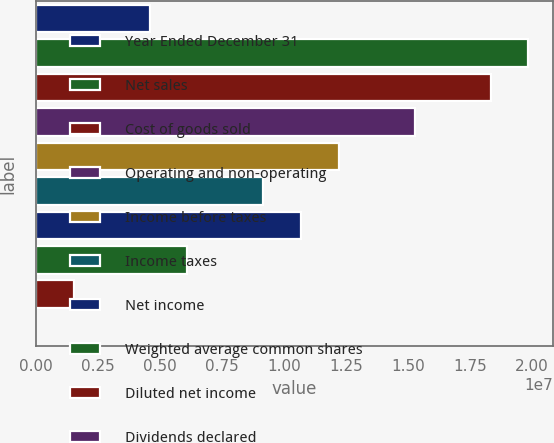Convert chart. <chart><loc_0><loc_0><loc_500><loc_500><bar_chart><fcel>Year Ended December 31<fcel>Net sales<fcel>Cost of goods sold<fcel>Operating and non-operating<fcel>Income before taxes<fcel>Income taxes<fcel>Net income<fcel>Weighted average common shares<fcel>Diluted net income<fcel>Dividends declared<nl><fcel>4.58401e+06<fcel>1.98641e+07<fcel>1.83361e+07<fcel>1.528e+07<fcel>1.2224e+07<fcel>9.16803e+06<fcel>1.0696e+07<fcel>6.11202e+06<fcel>1.52801e+06<fcel>2.46<nl></chart> 